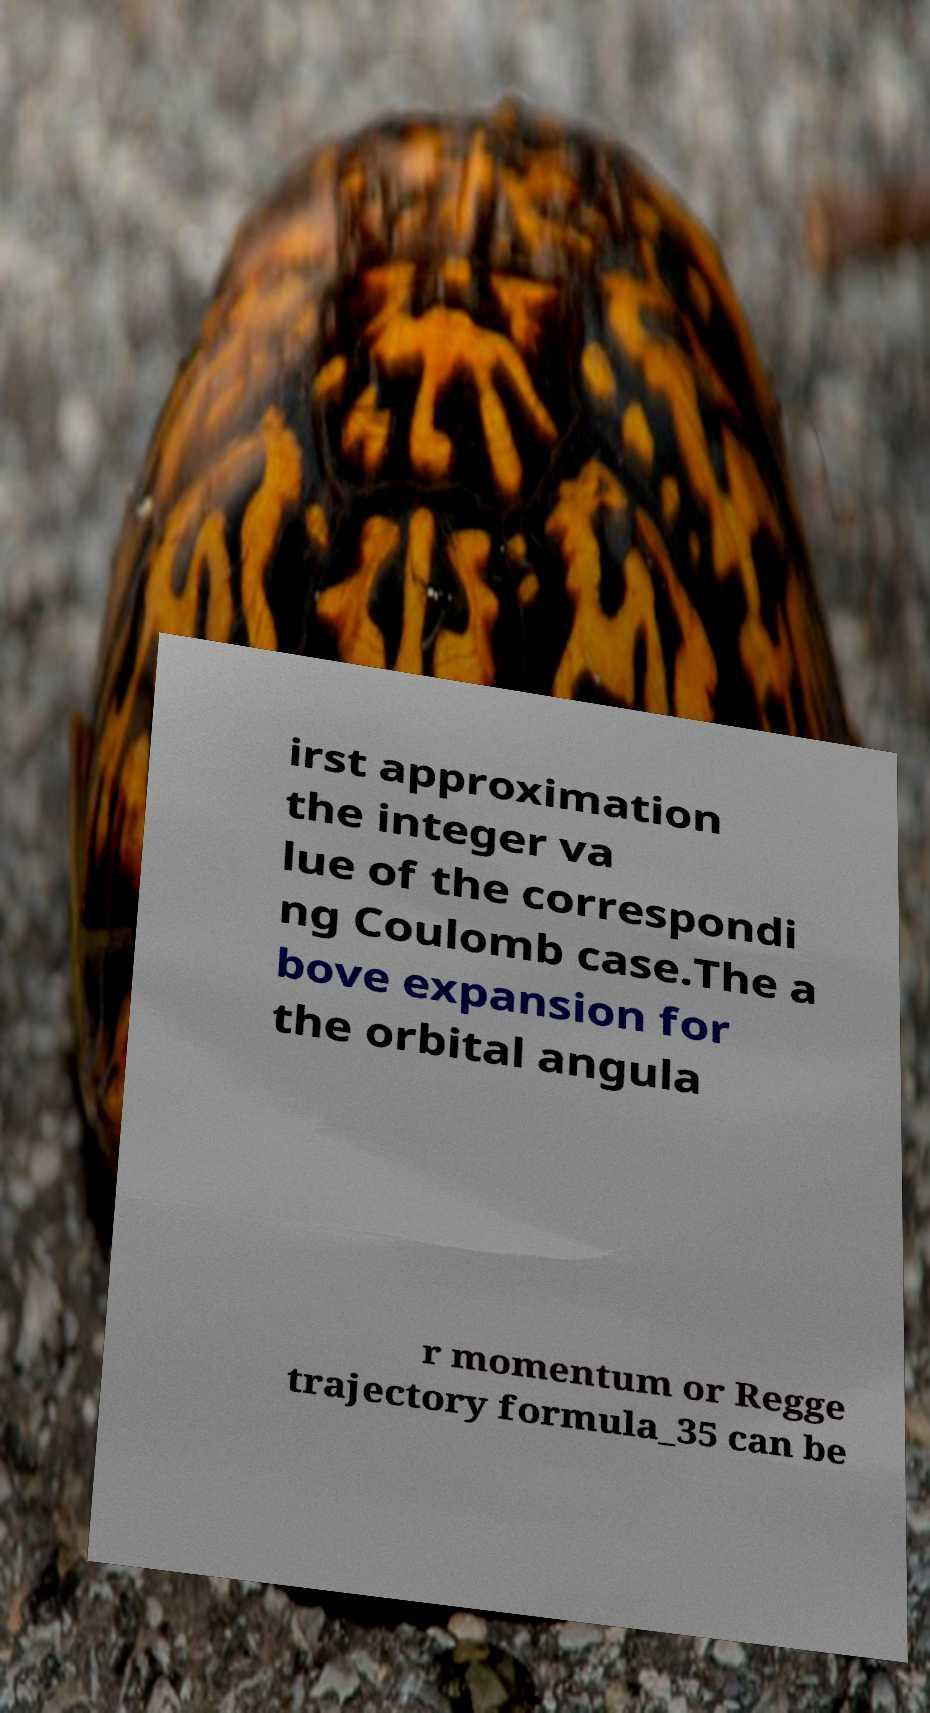Could you extract and type out the text from this image? irst approximation the integer va lue of the correspondi ng Coulomb case.The a bove expansion for the orbital angula r momentum or Regge trajectory formula_35 can be 